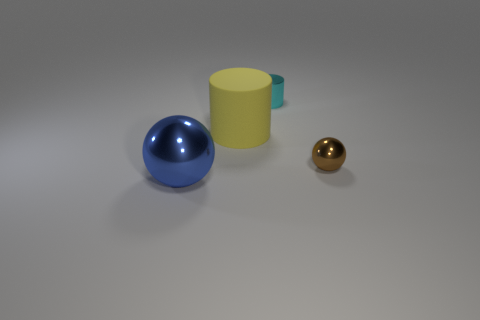How big is the sphere that is right of the sphere on the left side of the yellow cylinder?
Ensure brevity in your answer.  Small. What is the material of the yellow object that is the same size as the blue metallic sphere?
Offer a terse response. Rubber. What number of other things are the same size as the cyan cylinder?
Offer a terse response. 1. What number of blocks are either tiny metal things or tiny cyan metallic things?
Give a very brief answer. 0. Is there anything else that is made of the same material as the blue object?
Provide a short and direct response. Yes. There is a large thing that is behind the metallic ball that is in front of the sphere that is on the right side of the small cyan cylinder; what is its material?
Provide a succinct answer. Rubber. What number of other tiny things are the same material as the yellow thing?
Your response must be concise. 0. Is the size of the ball to the right of the blue sphere the same as the large metallic sphere?
Offer a terse response. No. There is a tiny thing that is made of the same material as the tiny cyan cylinder; what is its color?
Your answer should be very brief. Brown. What number of metallic cylinders are left of the big rubber cylinder?
Provide a succinct answer. 0. 